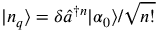<formula> <loc_0><loc_0><loc_500><loc_500>| n _ { q } \rangle = \delta \hat { a } ^ { \dagger n } | \alpha _ { 0 } \rangle / \sqrt { n ! }</formula> 